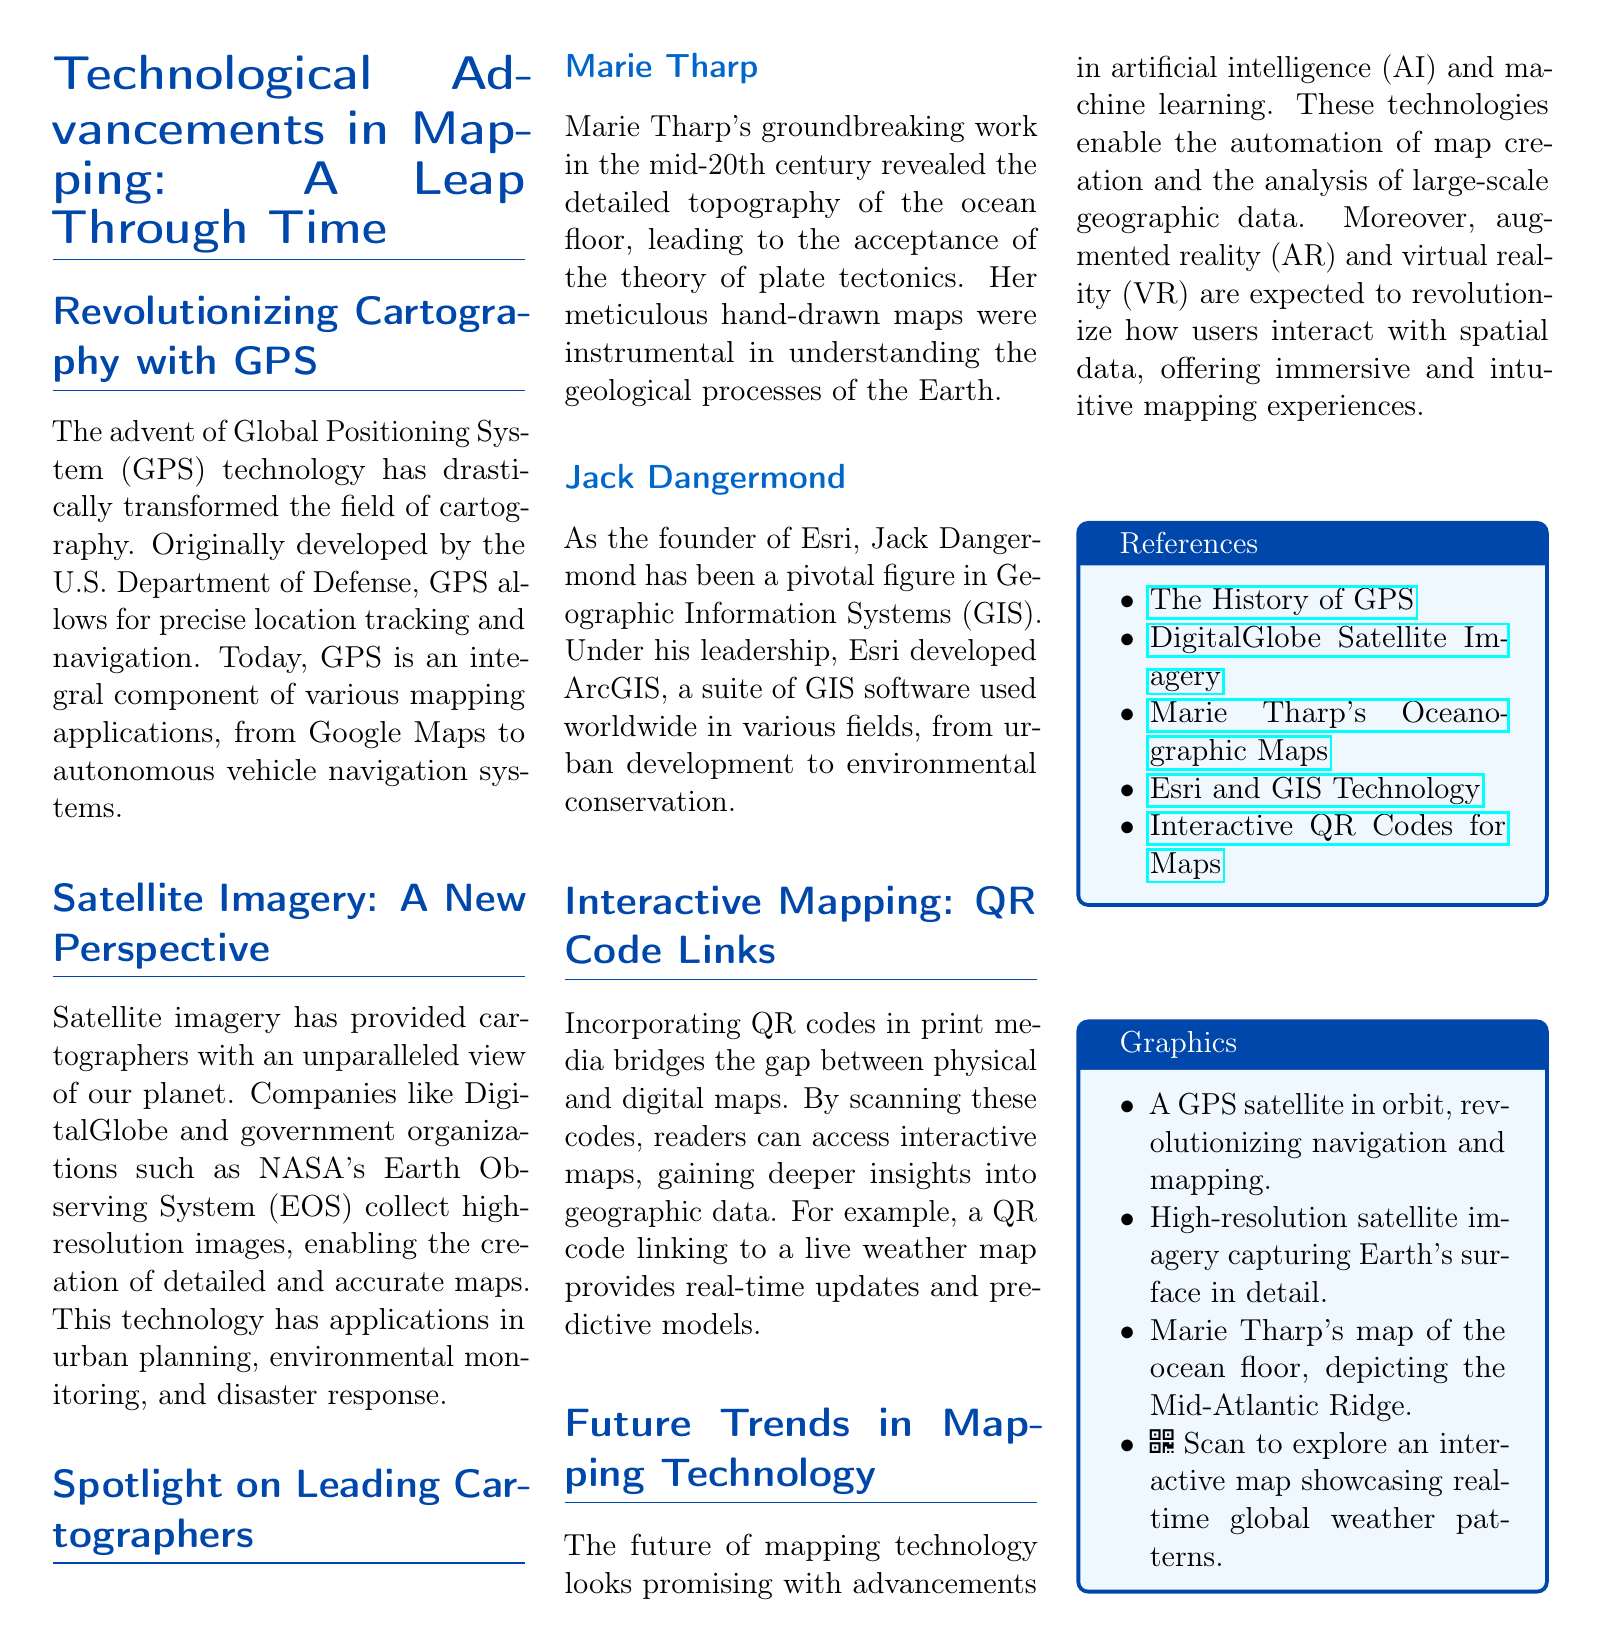What technology has transformed cartography? The document states that GPS technology has drastically transformed the field of cartography.
Answer: GPS technology Who revealed the ocean floor's topography? Marie Tharp's work revealed the detailed topography of the ocean floor.
Answer: Marie Tharp What company did Jack Dangermond found? The document mentions that Jack Dangermond is the founder of Esri.
Answer: Esri What technology is used for real-time mapping access? The document describes interactive QR codes that link to digital maps.
Answer: QR codes What perspective has satellite imagery provided? Satellite imagery has provided cartographers with an unparalleled view of our planet.
Answer: Unparalleled view What future technologies are expected to impact mapping? The document highlights advancements in artificial intelligence and machine learning as future impacts.
Answer: Artificial intelligence and machine learning How are QR codes utilized in mapping? The document explains that QR codes bridge the gap between physical and digital maps.
Answer: Bridge the gap between physical and digital maps What was the significant contribution of Marie Tharp? Her meticulous hand-drawn maps were instrumental in understanding the geological processes of the Earth.
Answer: Meticulous hand-drawn maps What is the purpose of the graphics section in the document? It lists visual elements related to mapping advances and historical contributions.
Answer: Lists visual elements related to mapping advances 